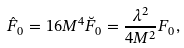Convert formula to latex. <formula><loc_0><loc_0><loc_500><loc_500>\hat { F } _ { 0 } = 1 6 M ^ { 4 } \breve { F } _ { 0 } = \frac { \lambda ^ { 2 } } { 4 M ^ { 2 } } F _ { 0 } ,</formula> 